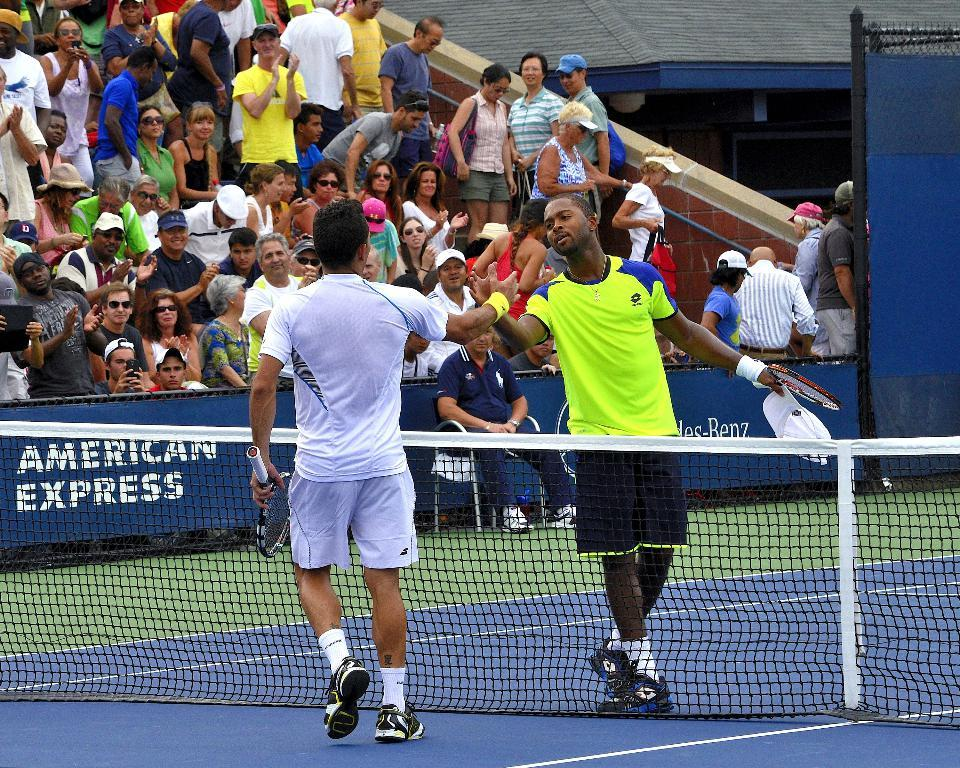How many people are present in the image? There are two people in the image. What are the two people doing? The two people are walking. What objects are the two people holding? The two people are holding rackets. What separates the two people? There is a net between the two people. What can be seen in the background of the image? There is a hoarding and people who appear to be an audience in the background of the image. What type of tank is visible in the image? There is no tank present in the image. What structure is being graded in the image? There is no structure or grading activity depicted in the image. 